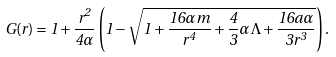Convert formula to latex. <formula><loc_0><loc_0><loc_500><loc_500>G ( r ) = 1 + \frac { r ^ { 2 } } { 4 \alpha } \left ( 1 - \sqrt { 1 + \frac { 1 6 \alpha m } { r ^ { 4 } } + \frac { 4 } { 3 } \alpha \Lambda + \frac { 1 6 a \alpha } { 3 r ^ { 3 } } } \right ) .</formula> 